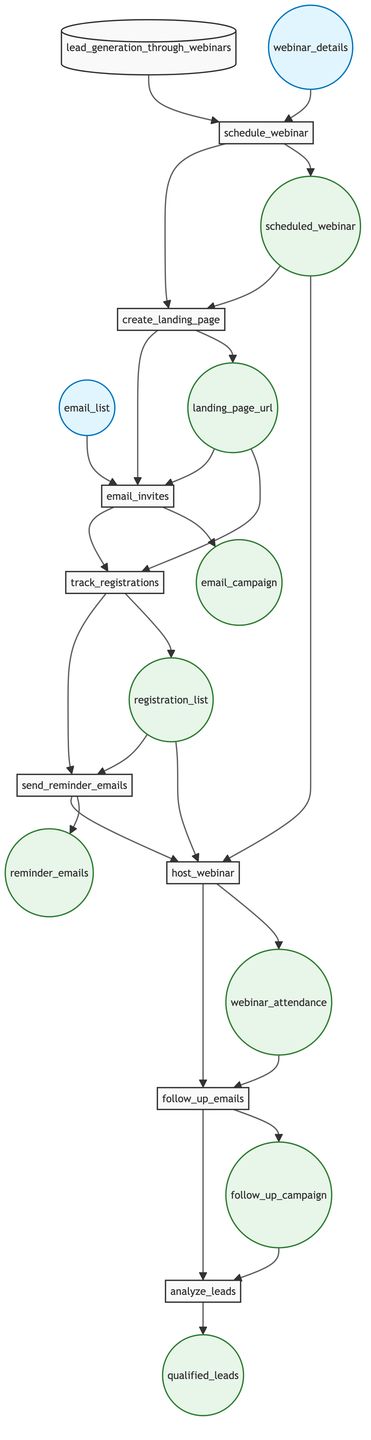What is the first action in the flowchart? The first action in the flowchart is labeled "schedule_webinar," indicating the initial step to be taken in the lead generation process.
Answer: schedule_webinar How many output nodes are there in the diagram? By counting the distinct output nodes, we find there are eight output nodes: scheduled_webinar, landing_page_url, email_campaign, registration_list, reminder_emails, webinar_attendance, follow_up_campaign, and qualified_leads.
Answer: 8 What are the inputs for the "email_invites" step? The "email_invites" step requires two inputs: email_list and landing_page_url, as these are the necessary components to send invitations efficiently.
Answer: email_list, landing_page_url Which step comes after "track_registrations"? Following the "track_registrations" step, the next action in the flowchart is "send_reminder_emails," indicating that reminders will be sent to those who registered.
Answer: send_reminder_emails What output do you get from the "host_webinar" step? The output from the "host_webinar" step is "webinar_attendance," as this represents the attendees present during the hosted webinar.
Answer: webinar_attendance How many total steps are involved in this lead generation process? The diagram displays a total of eight steps from "schedule_webinar" to "analyze_leads," showing the entire lead generation sequence.
Answer: 8 What is the final action performed in the process? The last action of the flowchart is "analyze_leads," where the leads are assessed and the CRM system is updated based on the follow-up campaign details.
Answer: analyze_leads Which action is performed directly after sending reminder emails? After the action "send_reminder_emails," the next step outlined in the flowchart is to "host_webinar," indicating the transition to the live event.
Answer: host_webinar What is required to create the landing page? The creation of the landing page requires the output from the "schedule_webinar" step, known as "scheduled_webinar," to ensure all relevant details are included.
Answer: scheduled_webinar 